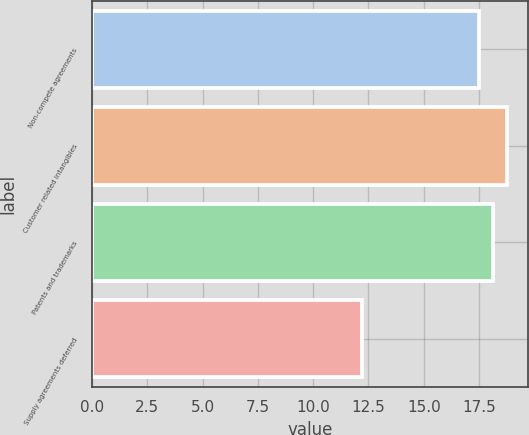<chart> <loc_0><loc_0><loc_500><loc_500><bar_chart><fcel>Non-compete agreements<fcel>Customer related intangibles<fcel>Patents and trademarks<fcel>Supply agreements deferred<nl><fcel>17.5<fcel>18.76<fcel>18.13<fcel>12.2<nl></chart> 